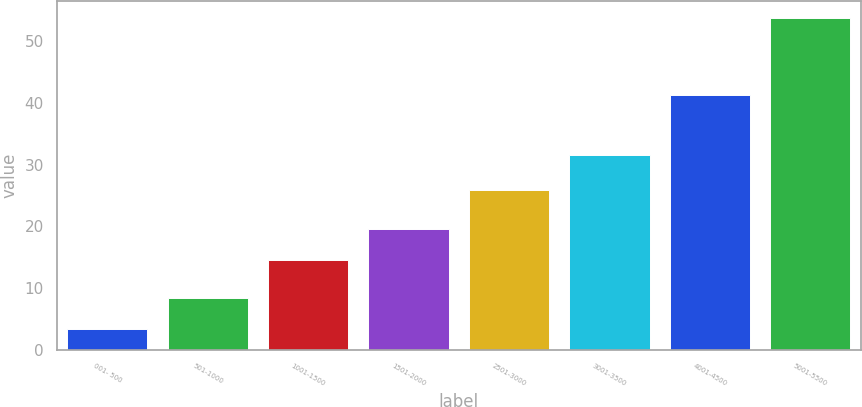<chart> <loc_0><loc_0><loc_500><loc_500><bar_chart><fcel>001- 500<fcel>501-1000<fcel>1001-1500<fcel>1501-2000<fcel>2501-3000<fcel>3001-3500<fcel>4001-4500<fcel>5001-5500<nl><fcel>3.38<fcel>8.42<fcel>14.45<fcel>19.49<fcel>25.85<fcel>31.49<fcel>41.25<fcel>53.78<nl></chart> 